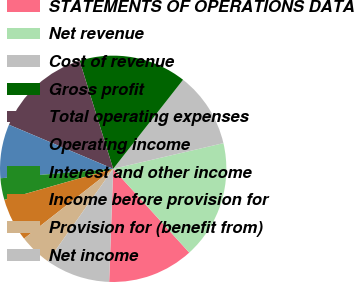Convert chart. <chart><loc_0><loc_0><loc_500><loc_500><pie_chart><fcel>STATEMENTS OF OPERATIONS DATA<fcel>Net revenue<fcel>Cost of revenue<fcel>Gross profit<fcel>Total operating expenses<fcel>Operating income<fcel>Interest and other income<fcel>Income before provision for<fcel>Provision for (benefit from)<fcel>Net income<nl><fcel>12.3%<fcel>16.91%<fcel>10.77%<fcel>15.38%<fcel>13.84%<fcel>7.7%<fcel>3.09%<fcel>6.16%<fcel>4.62%<fcel>9.23%<nl></chart> 